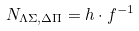Convert formula to latex. <formula><loc_0><loc_0><loc_500><loc_500>N _ { \Lambda \Sigma , \Delta \Pi } = h \cdot f ^ { - 1 }</formula> 